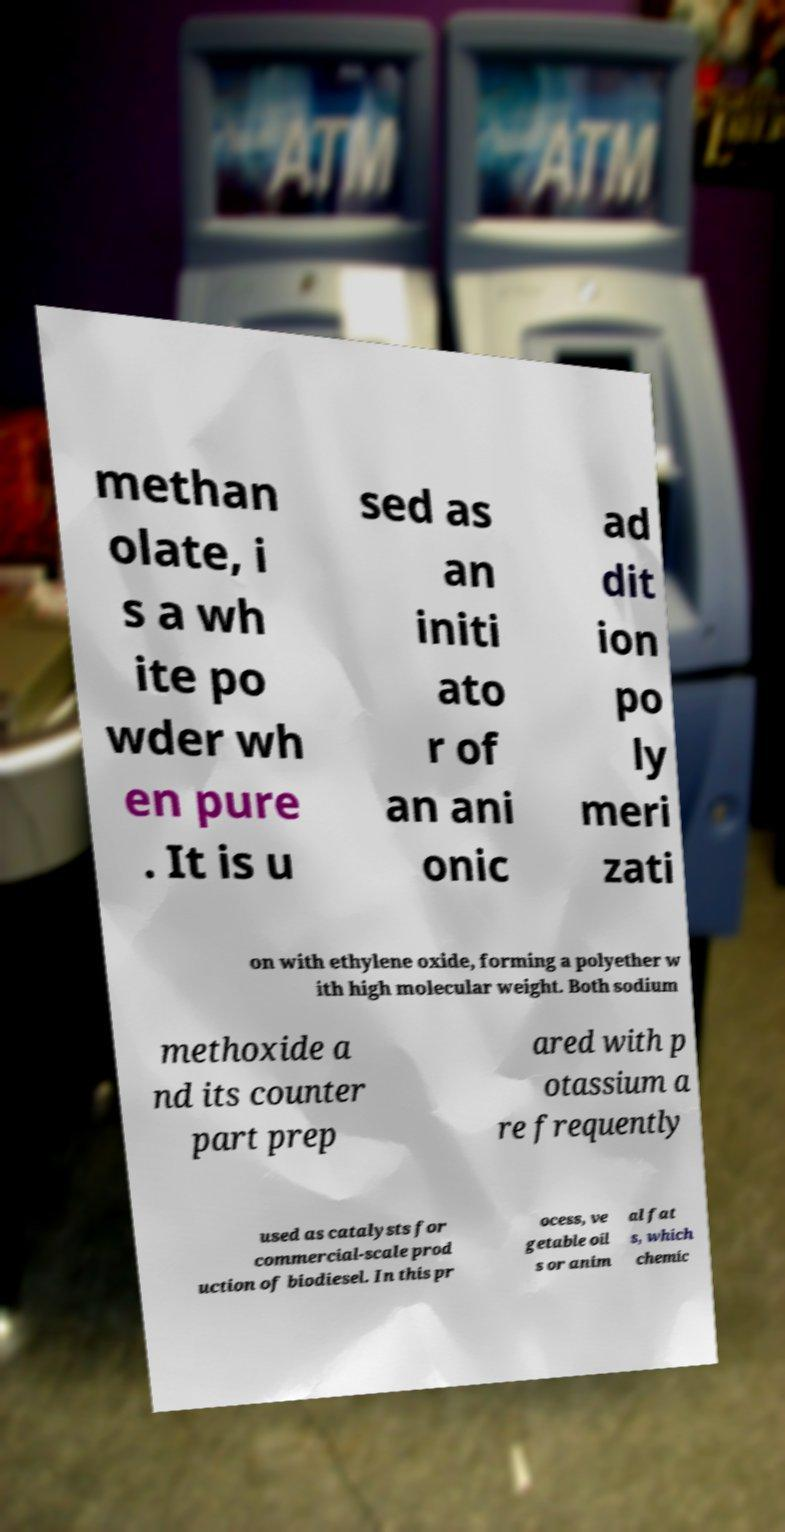Could you extract and type out the text from this image? methan olate, i s a wh ite po wder wh en pure . It is u sed as an initi ato r of an ani onic ad dit ion po ly meri zati on with ethylene oxide, forming a polyether w ith high molecular weight. Both sodium methoxide a nd its counter part prep ared with p otassium a re frequently used as catalysts for commercial-scale prod uction of biodiesel. In this pr ocess, ve getable oil s or anim al fat s, which chemic 